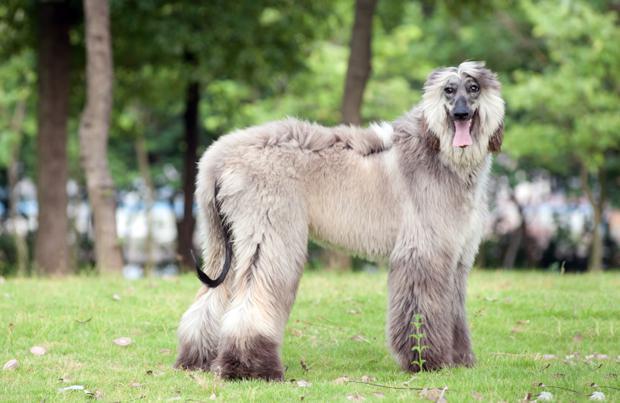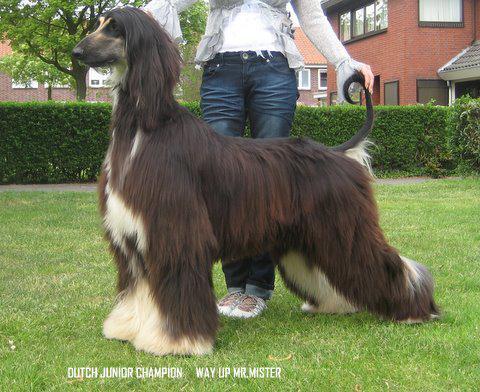The first image is the image on the left, the second image is the image on the right. Assess this claim about the two images: "There is a dog running in one of the images.". Correct or not? Answer yes or no. No. The first image is the image on the left, the second image is the image on the right. For the images displayed, is the sentence "One image shows a hound bounding across the grass." factually correct? Answer yes or no. No. 